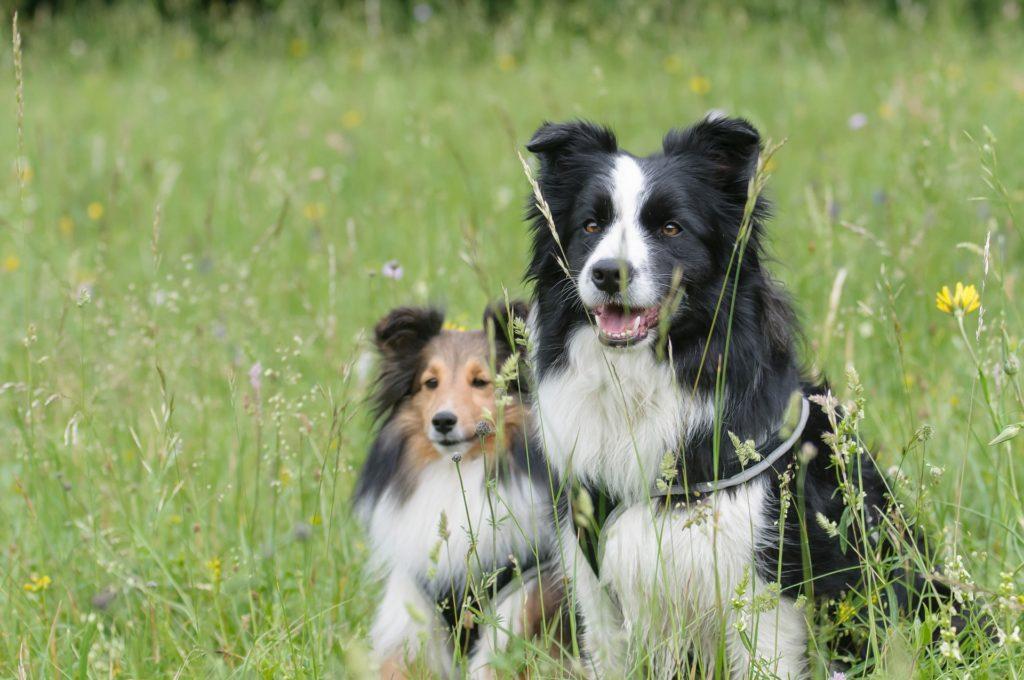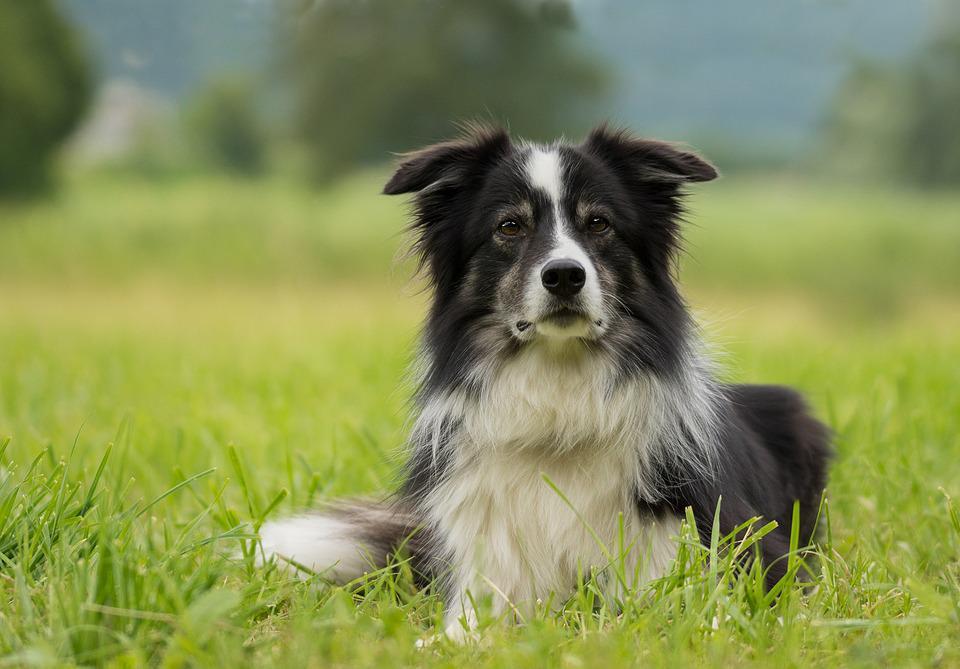The first image is the image on the left, the second image is the image on the right. Examine the images to the left and right. Is the description "The right image shows a border collie hunched near the ground and facing right." accurate? Answer yes or no. No. 